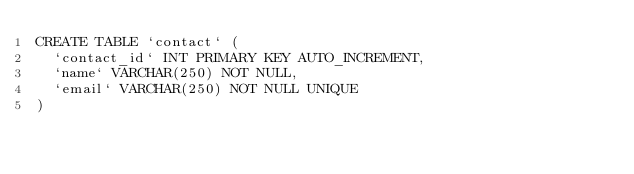<code> <loc_0><loc_0><loc_500><loc_500><_SQL_>CREATE TABLE `contact` (
  `contact_id` INT PRIMARY KEY AUTO_INCREMENT,
  `name` VARCHAR(250) NOT NULL,
  `email` VARCHAR(250) NOT NULL UNIQUE
)</code> 